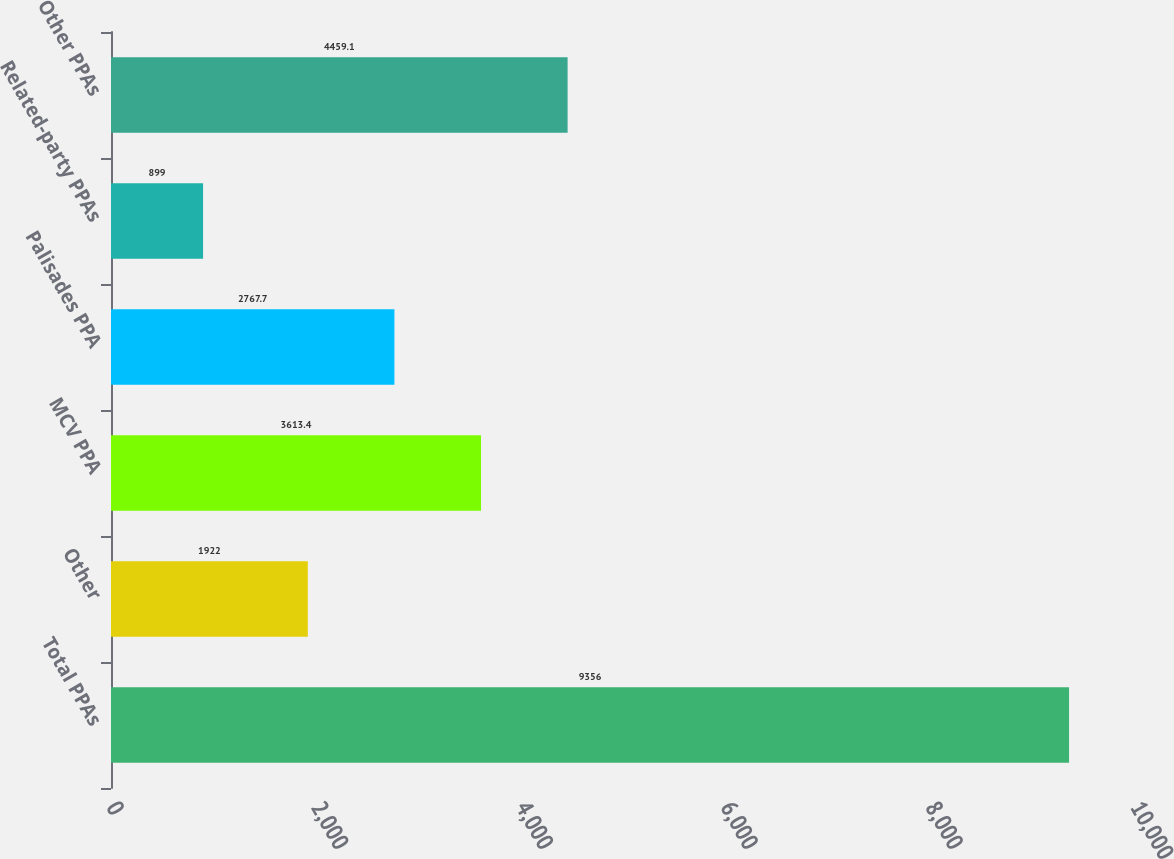Convert chart. <chart><loc_0><loc_0><loc_500><loc_500><bar_chart><fcel>Total PPAs<fcel>Other<fcel>MCV PPA<fcel>Palisades PPA<fcel>Related-party PPAs<fcel>Other PPAs<nl><fcel>9356<fcel>1922<fcel>3613.4<fcel>2767.7<fcel>899<fcel>4459.1<nl></chart> 